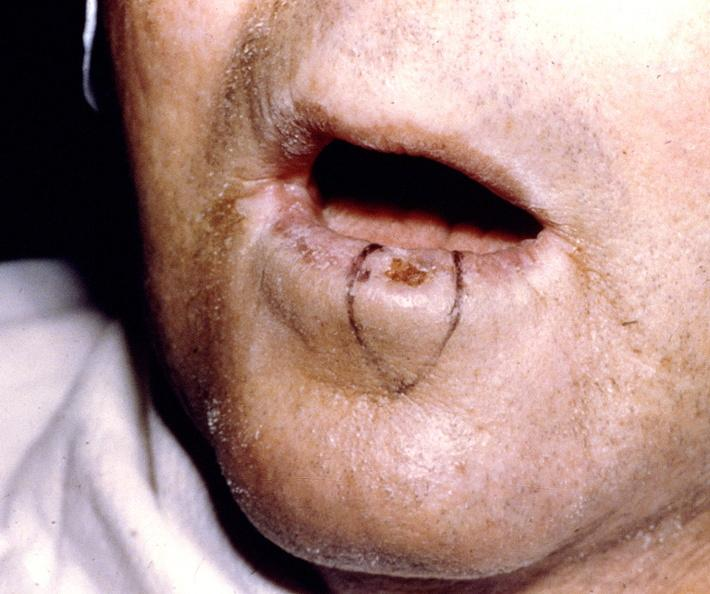s gastrointestinal present?
Answer the question using a single word or phrase. Yes 